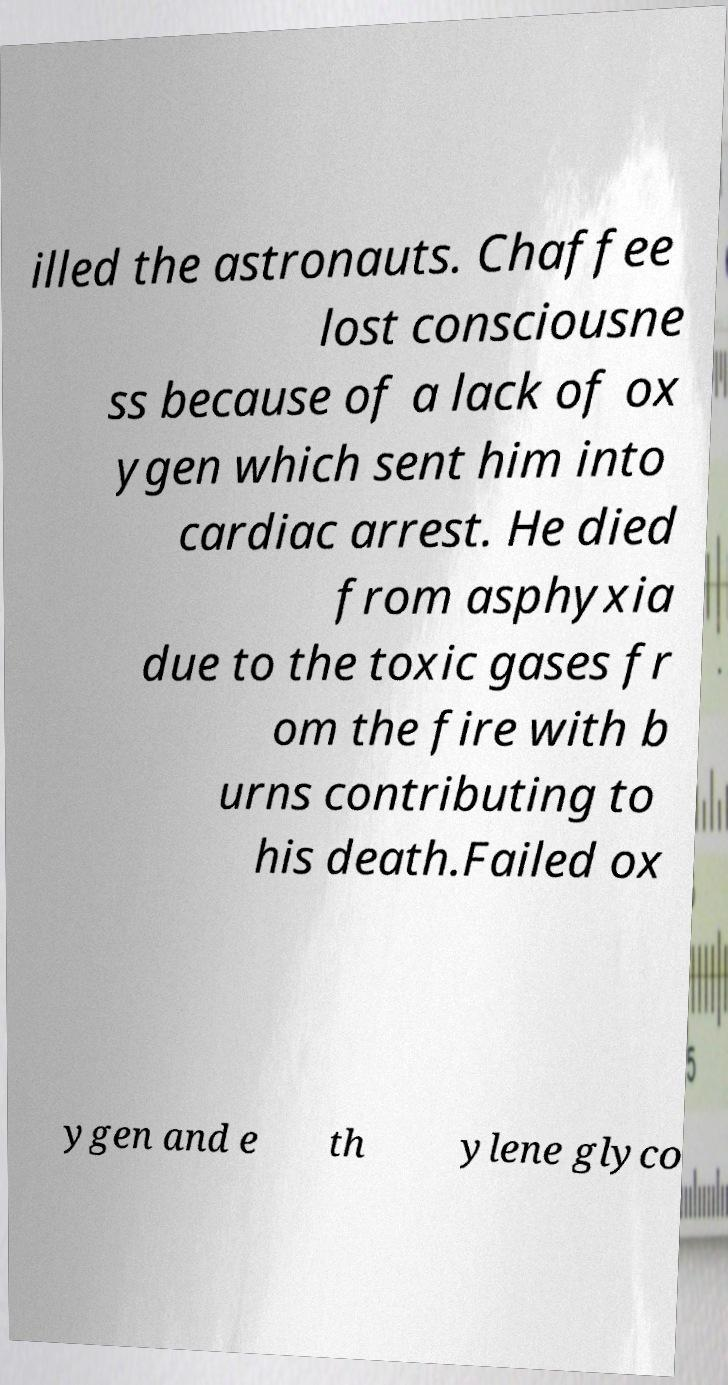Could you extract and type out the text from this image? illed the astronauts. Chaffee lost consciousne ss because of a lack of ox ygen which sent him into cardiac arrest. He died from asphyxia due to the toxic gases fr om the fire with b urns contributing to his death.Failed ox ygen and e th ylene glyco 